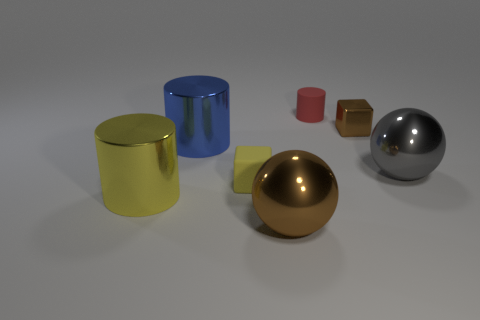What is the shape of the big metallic thing that is the same color as the matte block?
Offer a terse response. Cylinder. Is there anything else that has the same color as the small shiny thing?
Your answer should be compact. Yes. The large shiny thing that is both in front of the yellow matte cube and on the left side of the small yellow thing has what shape?
Offer a terse response. Cylinder. Does the tiny rubber cube have the same color as the big shiny cylinder in front of the gray metallic thing?
Provide a short and direct response. Yes. Does the cylinder to the left of the blue thing have the same size as the red matte cylinder?
Give a very brief answer. No. There is another yellow object that is the same shape as the tiny shiny object; what material is it?
Offer a very short reply. Rubber. Does the yellow matte thing have the same shape as the small metal thing?
Your response must be concise. Yes. What number of yellow blocks are in front of the big metal ball that is on the left side of the large gray shiny sphere?
Keep it short and to the point. 0. There is a tiny red thing that is made of the same material as the yellow cube; what is its shape?
Make the answer very short. Cylinder. What number of yellow things are either small metal cubes or large metal cylinders?
Your answer should be very brief. 1. 